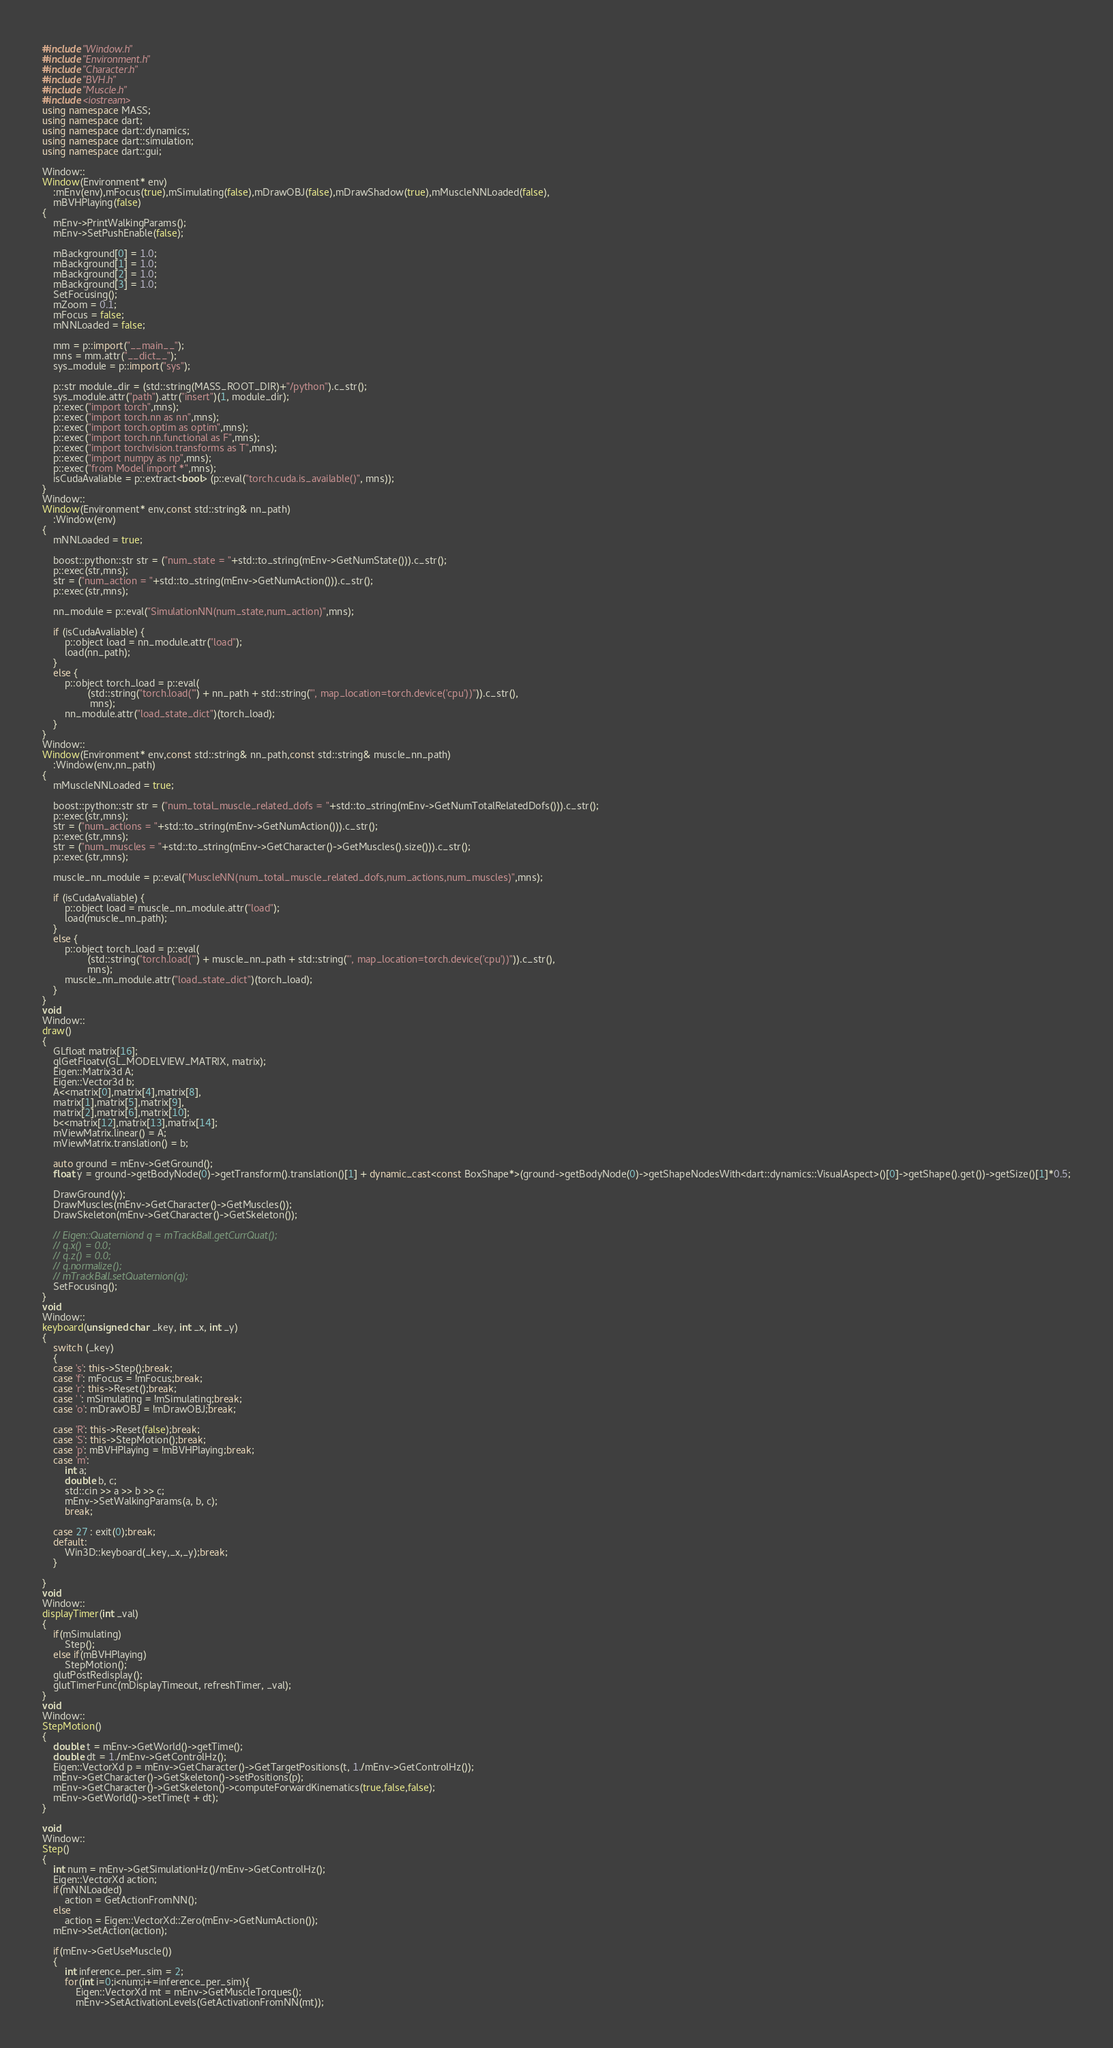<code> <loc_0><loc_0><loc_500><loc_500><_C++_>#include "Window.h"
#include "Environment.h"
#include "Character.h"
#include "BVH.h"
#include "Muscle.h"
#include <iostream>
using namespace MASS;
using namespace dart;
using namespace dart::dynamics;
using namespace dart::simulation;
using namespace dart::gui;

Window::
Window(Environment* env)
	:mEnv(env),mFocus(true),mSimulating(false),mDrawOBJ(false),mDrawShadow(true),mMuscleNNLoaded(false),
	mBVHPlaying(false)
{
	mEnv->PrintWalkingParams();
	mEnv->SetPushEnable(false);

	mBackground[0] = 1.0;
	mBackground[1] = 1.0;
	mBackground[2] = 1.0;
	mBackground[3] = 1.0;
	SetFocusing();
	mZoom = 0.1;
	mFocus = false;
	mNNLoaded = false;

	mm = p::import("__main__");
	mns = mm.attr("__dict__");
	sys_module = p::import("sys");

	p::str module_dir = (std::string(MASS_ROOT_DIR)+"/python").c_str();
	sys_module.attr("path").attr("insert")(1, module_dir);
	p::exec("import torch",mns);
	p::exec("import torch.nn as nn",mns);
	p::exec("import torch.optim as optim",mns);
	p::exec("import torch.nn.functional as F",mns);
	p::exec("import torchvision.transforms as T",mns);
	p::exec("import numpy as np",mns);
	p::exec("from Model import *",mns);
    isCudaAvaliable = p::extract<bool> (p::eval("torch.cuda.is_available()", mns));
}
Window::
Window(Environment* env,const std::string& nn_path)
	:Window(env)
{
	mNNLoaded = true;

	boost::python::str str = ("num_state = "+std::to_string(mEnv->GetNumState())).c_str();
	p::exec(str,mns);
	str = ("num_action = "+std::to_string(mEnv->GetNumAction())).c_str();
	p::exec(str,mns);

	nn_module = p::eval("SimulationNN(num_state,num_action)",mns);

	if (isCudaAvaliable) {
        p::object load = nn_module.attr("load");
        load(nn_path);
    }
	else {
	    p::object torch_load = p::eval(
                (std::string("torch.load('") + nn_path + std::string("', map_location=torch.device('cpu'))")).c_str(),
                 mns);
	    nn_module.attr("load_state_dict")(torch_load);
	}
}
Window::
Window(Environment* env,const std::string& nn_path,const std::string& muscle_nn_path)
	:Window(env,nn_path)
{
	mMuscleNNLoaded = true;

	boost::python::str str = ("num_total_muscle_related_dofs = "+std::to_string(mEnv->GetNumTotalRelatedDofs())).c_str();
	p::exec(str,mns);
	str = ("num_actions = "+std::to_string(mEnv->GetNumAction())).c_str();
	p::exec(str,mns);
	str = ("num_muscles = "+std::to_string(mEnv->GetCharacter()->GetMuscles().size())).c_str();
	p::exec(str,mns);

	muscle_nn_module = p::eval("MuscleNN(num_total_muscle_related_dofs,num_actions,num_muscles)",mns);

    if (isCudaAvaliable) {
        p::object load = muscle_nn_module.attr("load");
        load(muscle_nn_path);
    }
    else {
        p::object torch_load = p::eval(
                (std::string("torch.load('") + muscle_nn_path + std::string("', map_location=torch.device('cpu'))")).c_str(),
                mns);
        muscle_nn_module.attr("load_state_dict")(torch_load);
    }
}
void
Window::
draw()
{	
	GLfloat matrix[16];
	glGetFloatv(GL_MODELVIEW_MATRIX, matrix);
	Eigen::Matrix3d A;
	Eigen::Vector3d b;
	A<<matrix[0],matrix[4],matrix[8],
	matrix[1],matrix[5],matrix[9],
	matrix[2],matrix[6],matrix[10];
	b<<matrix[12],matrix[13],matrix[14];
	mViewMatrix.linear() = A;
	mViewMatrix.translation() = b;

	auto ground = mEnv->GetGround();
	float y = ground->getBodyNode(0)->getTransform().translation()[1] + dynamic_cast<const BoxShape*>(ground->getBodyNode(0)->getShapeNodesWith<dart::dynamics::VisualAspect>()[0]->getShape().get())->getSize()[1]*0.5;
	
	DrawGround(y);
	DrawMuscles(mEnv->GetCharacter()->GetMuscles());
	DrawSkeleton(mEnv->GetCharacter()->GetSkeleton());

	// Eigen::Quaterniond q = mTrackBall.getCurrQuat();
	// q.x() = 0.0;
	// q.z() = 0.0;
	// q.normalize();
	// mTrackBall.setQuaternion(q);
	SetFocusing();
}
void
Window::
keyboard(unsigned char _key, int _x, int _y)
{
	switch (_key)
	{
	case 's': this->Step();break;
	case 'f': mFocus = !mFocus;break;
	case 'r': this->Reset();break;
	case ' ': mSimulating = !mSimulating;break;
	case 'o': mDrawOBJ = !mDrawOBJ;break;

	case 'R': this->Reset(false);break;
    case 'S': this->StepMotion();break;
	case 'p': mBVHPlaying = !mBVHPlaying;break;
	case 'm':
	    int a;
	    double b, c;
	    std::cin >> a >> b >> c;
	    mEnv->SetWalkingParams(a, b, c);
	    break;

	case 27 : exit(0);break;
	default:
		Win3D::keyboard(_key,_x,_y);break;
	}

}
void
Window::
displayTimer(int _val)
{
	if(mSimulating)
		Step();
	else if(mBVHPlaying)
	    StepMotion();
	glutPostRedisplay();
	glutTimerFunc(mDisplayTimeout, refreshTimer, _val);
}
void
Window::
StepMotion()
{
    double t = mEnv->GetWorld()->getTime();
    double dt = 1./mEnv->GetControlHz();
    Eigen::VectorXd p = mEnv->GetCharacter()->GetTargetPositions(t, 1./mEnv->GetControlHz());
    mEnv->GetCharacter()->GetSkeleton()->setPositions(p);
    mEnv->GetCharacter()->GetSkeleton()->computeForwardKinematics(true,false,false);
    mEnv->GetWorld()->setTime(t + dt);
}

void
Window::
Step()
{	
	int num = mEnv->GetSimulationHz()/mEnv->GetControlHz();
	Eigen::VectorXd action;
	if(mNNLoaded)
		action = GetActionFromNN();
	else
		action = Eigen::VectorXd::Zero(mEnv->GetNumAction());
	mEnv->SetAction(action);

	if(mEnv->GetUseMuscle())
	{
		int inference_per_sim = 2;
		for(int i=0;i<num;i+=inference_per_sim){
			Eigen::VectorXd mt = mEnv->GetMuscleTorques();
			mEnv->SetActivationLevels(GetActivationFromNN(mt));</code> 